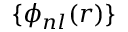<formula> <loc_0><loc_0><loc_500><loc_500>\{ \phi _ { n l } ( r ) \}</formula> 